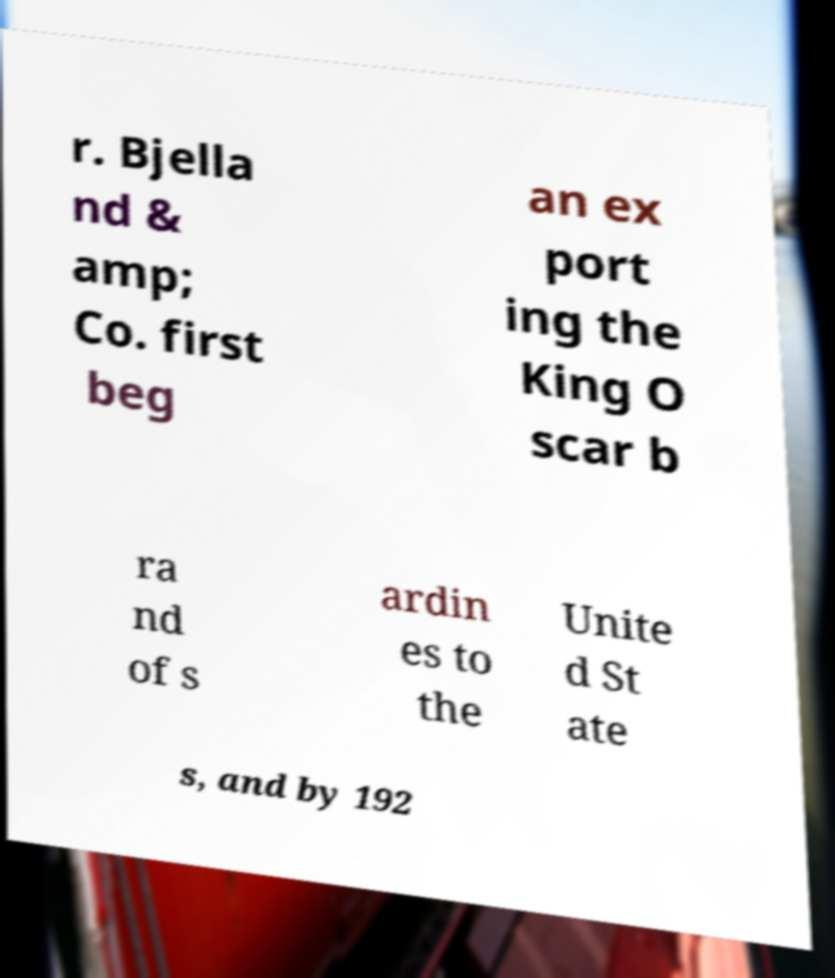Please read and relay the text visible in this image. What does it say? r. Bjella nd & amp; Co. first beg an ex port ing the King O scar b ra nd of s ardin es to the Unite d St ate s, and by 192 